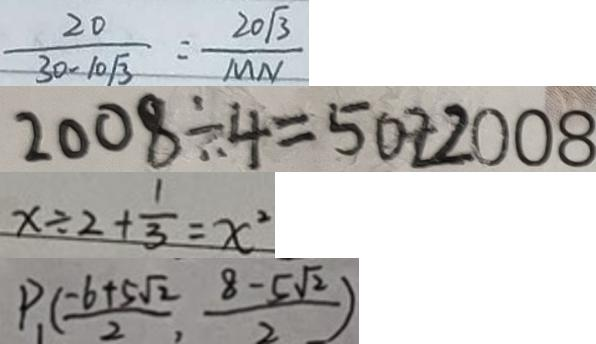<formula> <loc_0><loc_0><loc_500><loc_500>\frac { 2 0 } { 3 0 - 1 0 \sqrt { 3 } } = \frac { 2 0 \sqrt { 3 } } { M N } 
 2 0 0 8 \div 4 = 5 0 2 2 0 0 8 
 x \div 2 + \frac { 1 } { 3 } = x ^ { 2 } 
 P _ { 1 } ( \frac { - 6 + 5 \sqrt { 2 } } { 2 } , \frac { 8 - 5 \sqrt { 2 } } { 2 } )</formula> 